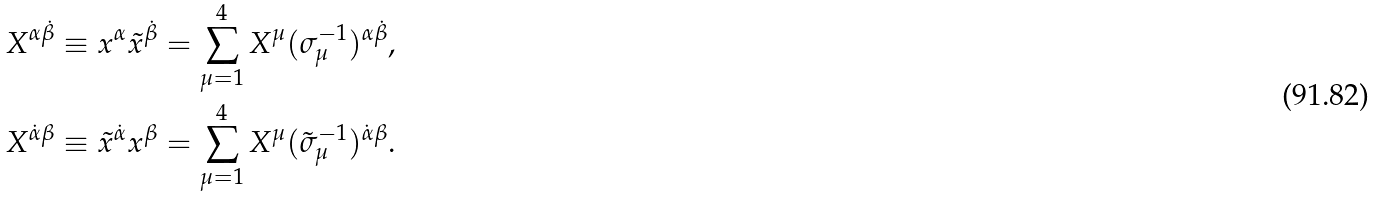<formula> <loc_0><loc_0><loc_500><loc_500>X ^ { \alpha \dot { \beta } } & \equiv x ^ { \alpha } \tilde { x } ^ { \dot { \beta } } = \sum _ { \mu = 1 } ^ { 4 } X ^ { \mu } ( \sigma _ { \mu } ^ { - 1 } ) ^ { \alpha \dot { \beta } } , \\ X ^ { \dot { \alpha } { \beta } } & \equiv \tilde { x } ^ { \dot { \alpha } } x ^ { \beta } = \sum _ { \mu = 1 } ^ { 4 } X ^ { \mu } ( \tilde { \sigma } _ { \mu } ^ { - 1 } ) ^ { \dot { \alpha } { \beta } } .</formula> 